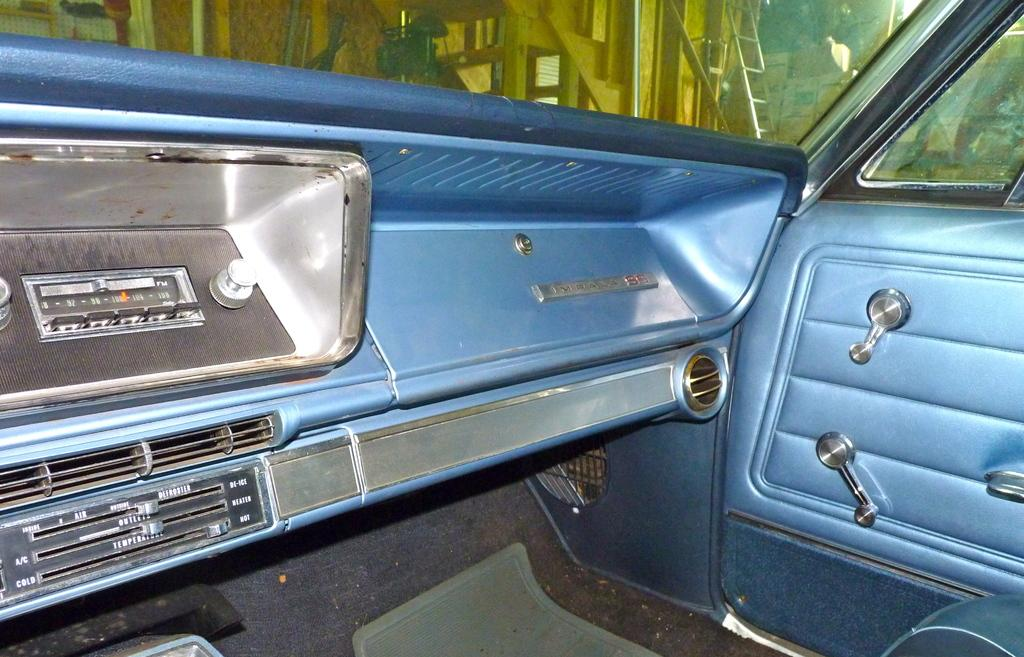What type of setting is depicted in the image? The image shows an inside view of a vehicle. What can be seen in the background of the image? There is a ladder and boxes in the background of the image. Can you see a plate on the ladder in the image? There is no plate visible on the ladder in the image. Is there a curtain hanging in the vehicle in the image? There is no mention of a curtain in the image, and it is not visible in the provided facts. 